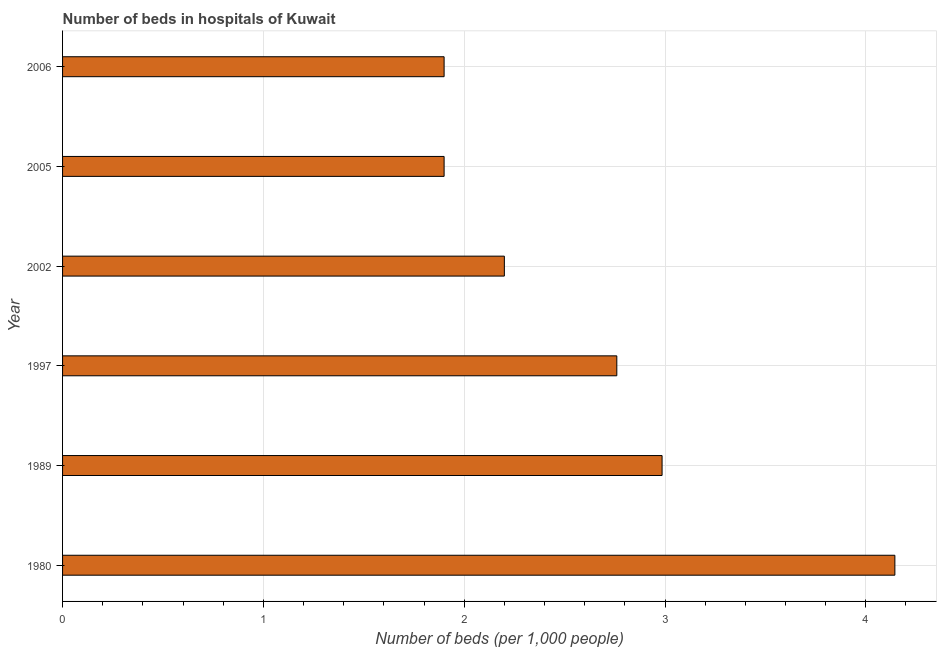What is the title of the graph?
Make the answer very short. Number of beds in hospitals of Kuwait. What is the label or title of the X-axis?
Provide a succinct answer. Number of beds (per 1,0 people). What is the number of hospital beds in 1989?
Offer a very short reply. 2.99. Across all years, what is the maximum number of hospital beds?
Your answer should be very brief. 4.14. In which year was the number of hospital beds maximum?
Offer a terse response. 1980. In which year was the number of hospital beds minimum?
Make the answer very short. 2005. What is the sum of the number of hospital beds?
Your answer should be very brief. 15.89. What is the difference between the number of hospital beds in 2002 and 2006?
Give a very brief answer. 0.3. What is the average number of hospital beds per year?
Your answer should be compact. 2.65. What is the median number of hospital beds?
Offer a very short reply. 2.48. Do a majority of the years between 1997 and 2005 (inclusive) have number of hospital beds greater than 3.6 %?
Ensure brevity in your answer.  No. What is the ratio of the number of hospital beds in 1997 to that in 2002?
Offer a very short reply. 1.25. Is the difference between the number of hospital beds in 1989 and 2005 greater than the difference between any two years?
Provide a succinct answer. No. What is the difference between the highest and the second highest number of hospital beds?
Give a very brief answer. 1.16. What is the difference between the highest and the lowest number of hospital beds?
Ensure brevity in your answer.  2.24. In how many years, is the number of hospital beds greater than the average number of hospital beds taken over all years?
Your answer should be very brief. 3. How many bars are there?
Give a very brief answer. 6. Are the values on the major ticks of X-axis written in scientific E-notation?
Give a very brief answer. No. What is the Number of beds (per 1,000 people) in 1980?
Your answer should be compact. 4.14. What is the Number of beds (per 1,000 people) of 1989?
Give a very brief answer. 2.99. What is the Number of beds (per 1,000 people) of 1997?
Ensure brevity in your answer.  2.76. What is the Number of beds (per 1,000 people) of 2002?
Provide a short and direct response. 2.2. What is the Number of beds (per 1,000 people) in 2005?
Make the answer very short. 1.9. What is the Number of beds (per 1,000 people) in 2006?
Your answer should be compact. 1.9. What is the difference between the Number of beds (per 1,000 people) in 1980 and 1989?
Your response must be concise. 1.16. What is the difference between the Number of beds (per 1,000 people) in 1980 and 1997?
Offer a very short reply. 1.38. What is the difference between the Number of beds (per 1,000 people) in 1980 and 2002?
Give a very brief answer. 1.94. What is the difference between the Number of beds (per 1,000 people) in 1980 and 2005?
Make the answer very short. 2.24. What is the difference between the Number of beds (per 1,000 people) in 1980 and 2006?
Offer a very short reply. 2.24. What is the difference between the Number of beds (per 1,000 people) in 1989 and 1997?
Provide a short and direct response. 0.23. What is the difference between the Number of beds (per 1,000 people) in 1989 and 2002?
Ensure brevity in your answer.  0.79. What is the difference between the Number of beds (per 1,000 people) in 1989 and 2005?
Your answer should be compact. 1.09. What is the difference between the Number of beds (per 1,000 people) in 1989 and 2006?
Your answer should be compact. 1.09. What is the difference between the Number of beds (per 1,000 people) in 1997 and 2002?
Your answer should be very brief. 0.56. What is the difference between the Number of beds (per 1,000 people) in 1997 and 2005?
Your answer should be very brief. 0.86. What is the difference between the Number of beds (per 1,000 people) in 1997 and 2006?
Ensure brevity in your answer.  0.86. What is the difference between the Number of beds (per 1,000 people) in 2002 and 2006?
Keep it short and to the point. 0.3. What is the difference between the Number of beds (per 1,000 people) in 2005 and 2006?
Ensure brevity in your answer.  0. What is the ratio of the Number of beds (per 1,000 people) in 1980 to that in 1989?
Ensure brevity in your answer.  1.39. What is the ratio of the Number of beds (per 1,000 people) in 1980 to that in 1997?
Make the answer very short. 1.5. What is the ratio of the Number of beds (per 1,000 people) in 1980 to that in 2002?
Your answer should be very brief. 1.88. What is the ratio of the Number of beds (per 1,000 people) in 1980 to that in 2005?
Ensure brevity in your answer.  2.18. What is the ratio of the Number of beds (per 1,000 people) in 1980 to that in 2006?
Your response must be concise. 2.18. What is the ratio of the Number of beds (per 1,000 people) in 1989 to that in 1997?
Keep it short and to the point. 1.08. What is the ratio of the Number of beds (per 1,000 people) in 1989 to that in 2002?
Your answer should be very brief. 1.36. What is the ratio of the Number of beds (per 1,000 people) in 1989 to that in 2005?
Your answer should be compact. 1.57. What is the ratio of the Number of beds (per 1,000 people) in 1989 to that in 2006?
Your answer should be compact. 1.57. What is the ratio of the Number of beds (per 1,000 people) in 1997 to that in 2002?
Give a very brief answer. 1.25. What is the ratio of the Number of beds (per 1,000 people) in 1997 to that in 2005?
Offer a terse response. 1.45. What is the ratio of the Number of beds (per 1,000 people) in 1997 to that in 2006?
Make the answer very short. 1.45. What is the ratio of the Number of beds (per 1,000 people) in 2002 to that in 2005?
Make the answer very short. 1.16. What is the ratio of the Number of beds (per 1,000 people) in 2002 to that in 2006?
Offer a very short reply. 1.16. What is the ratio of the Number of beds (per 1,000 people) in 2005 to that in 2006?
Offer a very short reply. 1. 